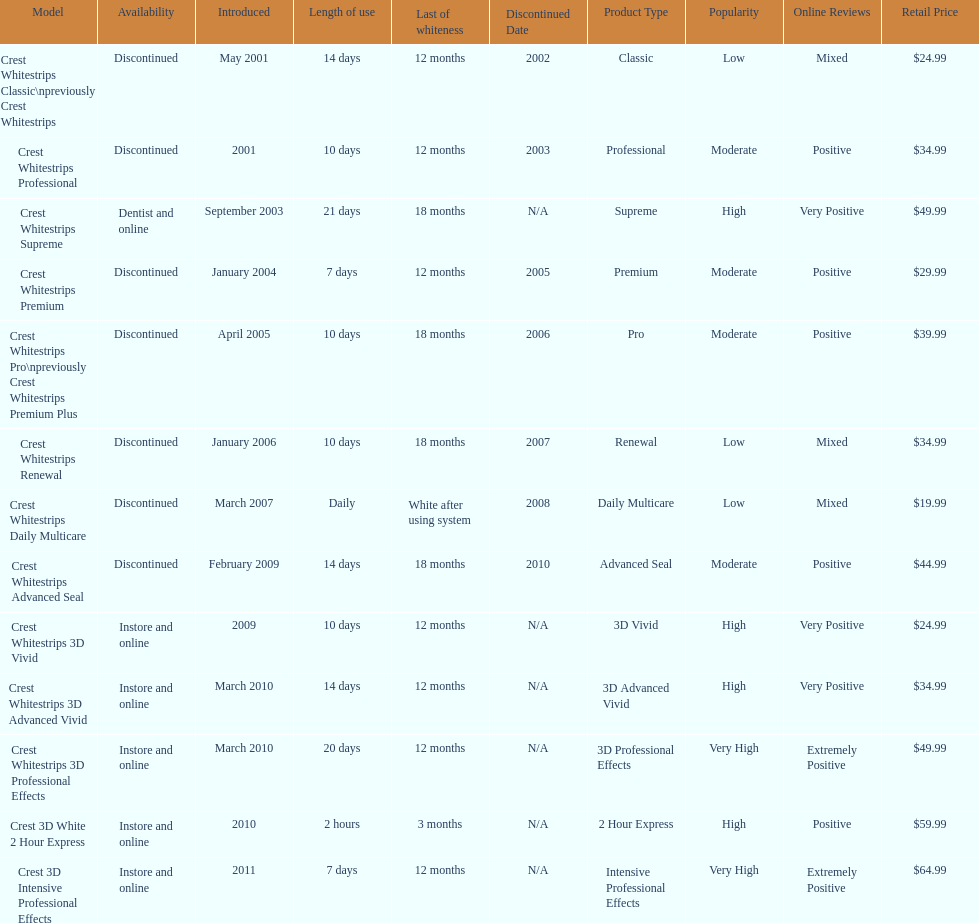Crest 3d intensive professional effects and crest whitestrips 3d professional effects both have a lasting whiteness of how many months? 12 months. 